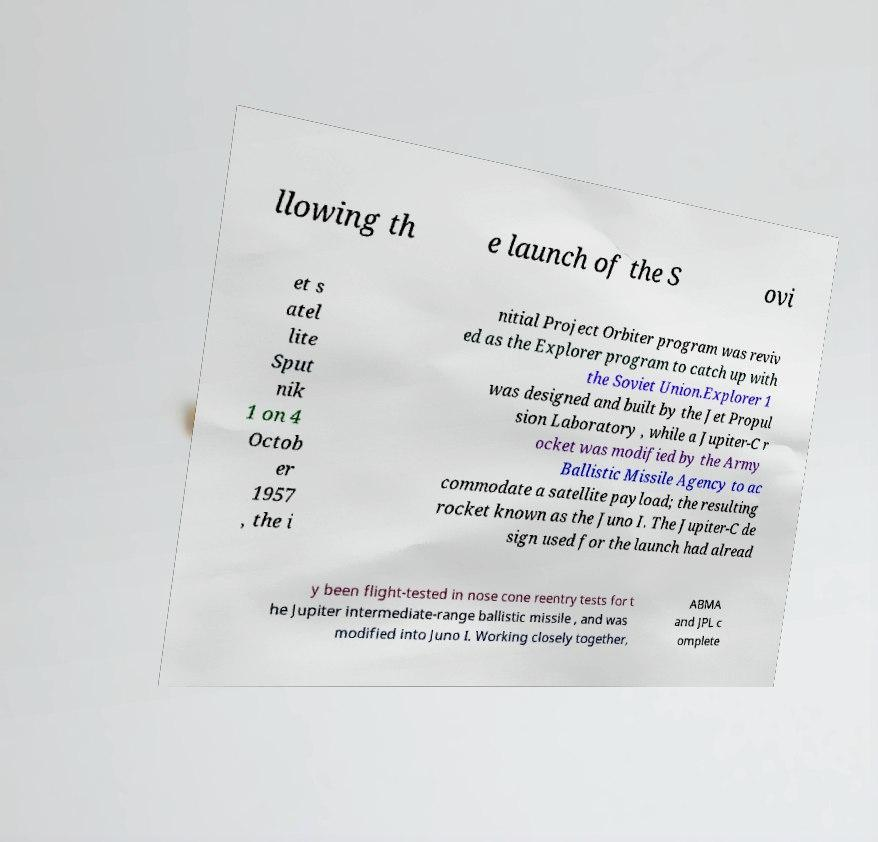Can you accurately transcribe the text from the provided image for me? llowing th e launch of the S ovi et s atel lite Sput nik 1 on 4 Octob er 1957 , the i nitial Project Orbiter program was reviv ed as the Explorer program to catch up with the Soviet Union.Explorer 1 was designed and built by the Jet Propul sion Laboratory , while a Jupiter-C r ocket was modified by the Army Ballistic Missile Agency to ac commodate a satellite payload; the resulting rocket known as the Juno I. The Jupiter-C de sign used for the launch had alread y been flight-tested in nose cone reentry tests for t he Jupiter intermediate-range ballistic missile , and was modified into Juno I. Working closely together, ABMA and JPL c omplete 